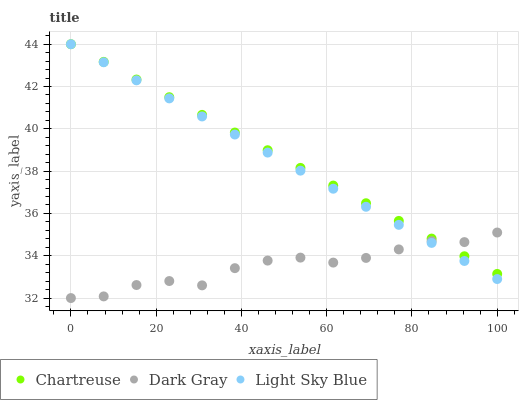Does Dark Gray have the minimum area under the curve?
Answer yes or no. Yes. Does Chartreuse have the maximum area under the curve?
Answer yes or no. Yes. Does Light Sky Blue have the minimum area under the curve?
Answer yes or no. No. Does Light Sky Blue have the maximum area under the curve?
Answer yes or no. No. Is Chartreuse the smoothest?
Answer yes or no. Yes. Is Dark Gray the roughest?
Answer yes or no. Yes. Is Light Sky Blue the smoothest?
Answer yes or no. No. Is Light Sky Blue the roughest?
Answer yes or no. No. Does Dark Gray have the lowest value?
Answer yes or no. Yes. Does Light Sky Blue have the lowest value?
Answer yes or no. No. Does Light Sky Blue have the highest value?
Answer yes or no. Yes. Does Chartreuse intersect Dark Gray?
Answer yes or no. Yes. Is Chartreuse less than Dark Gray?
Answer yes or no. No. Is Chartreuse greater than Dark Gray?
Answer yes or no. No. 